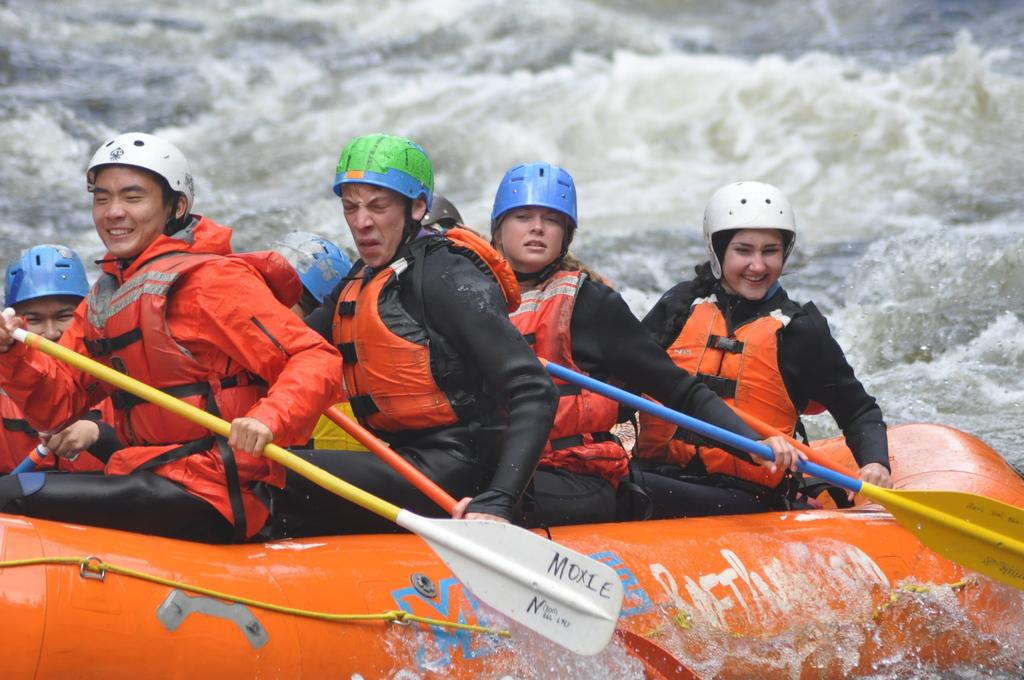How many people are in the image? There is a group of people in the image. What are the people holding in their hands? The people are holding paddles. What are the people sitting on in the image? The people are sitting on an inflatable boat. Where is the boat located in the image? The boat is on the water. What type of bikes can be seen in the image? There are no bikes present in the image; the people are sitting on an inflatable boat and holding paddles. 